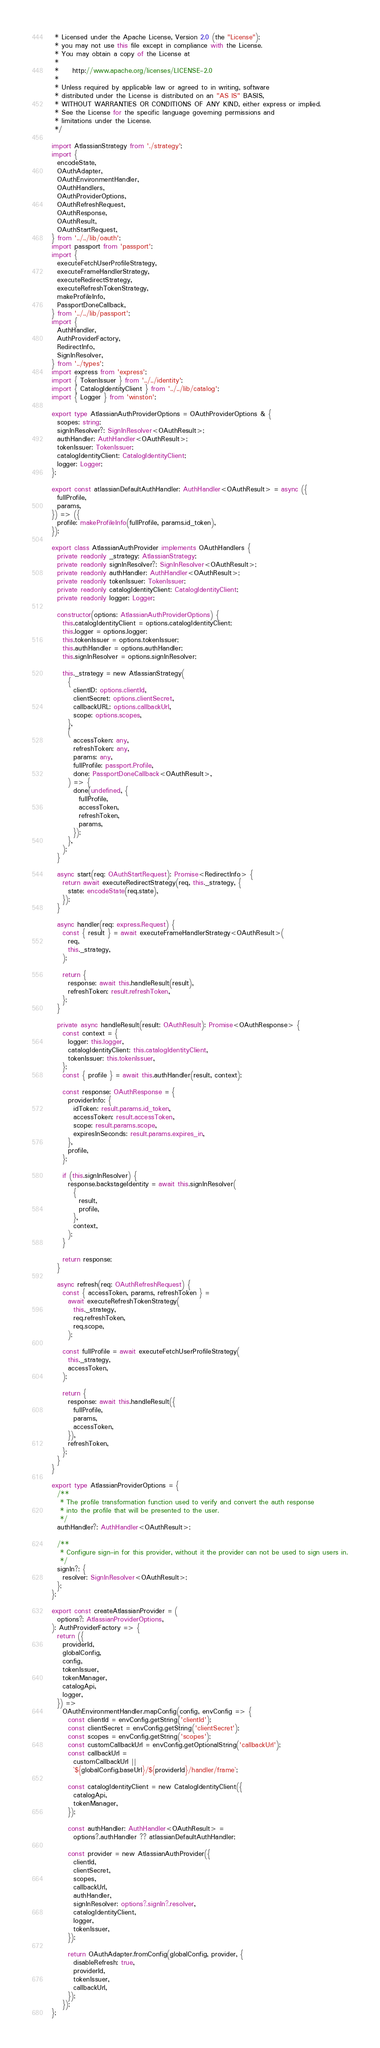<code> <loc_0><loc_0><loc_500><loc_500><_TypeScript_> * Licensed under the Apache License, Version 2.0 (the "License");
 * you may not use this file except in compliance with the License.
 * You may obtain a copy of the License at
 *
 *     http://www.apache.org/licenses/LICENSE-2.0
 *
 * Unless required by applicable law or agreed to in writing, software
 * distributed under the License is distributed on an "AS IS" BASIS,
 * WITHOUT WARRANTIES OR CONDITIONS OF ANY KIND, either express or implied.
 * See the License for the specific language governing permissions and
 * limitations under the License.
 */

import AtlassianStrategy from './strategy';
import {
  encodeState,
  OAuthAdapter,
  OAuthEnvironmentHandler,
  OAuthHandlers,
  OAuthProviderOptions,
  OAuthRefreshRequest,
  OAuthResponse,
  OAuthResult,
  OAuthStartRequest,
} from '../../lib/oauth';
import passport from 'passport';
import {
  executeFetchUserProfileStrategy,
  executeFrameHandlerStrategy,
  executeRedirectStrategy,
  executeRefreshTokenStrategy,
  makeProfileInfo,
  PassportDoneCallback,
} from '../../lib/passport';
import {
  AuthHandler,
  AuthProviderFactory,
  RedirectInfo,
  SignInResolver,
} from '../types';
import express from 'express';
import { TokenIssuer } from '../../identity';
import { CatalogIdentityClient } from '../../lib/catalog';
import { Logger } from 'winston';

export type AtlassianAuthProviderOptions = OAuthProviderOptions & {
  scopes: string;
  signInResolver?: SignInResolver<OAuthResult>;
  authHandler: AuthHandler<OAuthResult>;
  tokenIssuer: TokenIssuer;
  catalogIdentityClient: CatalogIdentityClient;
  logger: Logger;
};

export const atlassianDefaultAuthHandler: AuthHandler<OAuthResult> = async ({
  fullProfile,
  params,
}) => ({
  profile: makeProfileInfo(fullProfile, params.id_token),
});

export class AtlassianAuthProvider implements OAuthHandlers {
  private readonly _strategy: AtlassianStrategy;
  private readonly signInResolver?: SignInResolver<OAuthResult>;
  private readonly authHandler: AuthHandler<OAuthResult>;
  private readonly tokenIssuer: TokenIssuer;
  private readonly catalogIdentityClient: CatalogIdentityClient;
  private readonly logger: Logger;

  constructor(options: AtlassianAuthProviderOptions) {
    this.catalogIdentityClient = options.catalogIdentityClient;
    this.logger = options.logger;
    this.tokenIssuer = options.tokenIssuer;
    this.authHandler = options.authHandler;
    this.signInResolver = options.signInResolver;

    this._strategy = new AtlassianStrategy(
      {
        clientID: options.clientId,
        clientSecret: options.clientSecret,
        callbackURL: options.callbackUrl,
        scope: options.scopes,
      },
      (
        accessToken: any,
        refreshToken: any,
        params: any,
        fullProfile: passport.Profile,
        done: PassportDoneCallback<OAuthResult>,
      ) => {
        done(undefined, {
          fullProfile,
          accessToken,
          refreshToken,
          params,
        });
      },
    );
  }

  async start(req: OAuthStartRequest): Promise<RedirectInfo> {
    return await executeRedirectStrategy(req, this._strategy, {
      state: encodeState(req.state),
    });
  }

  async handler(req: express.Request) {
    const { result } = await executeFrameHandlerStrategy<OAuthResult>(
      req,
      this._strategy,
    );

    return {
      response: await this.handleResult(result),
      refreshToken: result.refreshToken,
    };
  }

  private async handleResult(result: OAuthResult): Promise<OAuthResponse> {
    const context = {
      logger: this.logger,
      catalogIdentityClient: this.catalogIdentityClient,
      tokenIssuer: this.tokenIssuer,
    };
    const { profile } = await this.authHandler(result, context);

    const response: OAuthResponse = {
      providerInfo: {
        idToken: result.params.id_token,
        accessToken: result.accessToken,
        scope: result.params.scope,
        expiresInSeconds: result.params.expires_in,
      },
      profile,
    };

    if (this.signInResolver) {
      response.backstageIdentity = await this.signInResolver(
        {
          result,
          profile,
        },
        context,
      );
    }

    return response;
  }

  async refresh(req: OAuthRefreshRequest) {
    const { accessToken, params, refreshToken } =
      await executeRefreshTokenStrategy(
        this._strategy,
        req.refreshToken,
        req.scope,
      );

    const fullProfile = await executeFetchUserProfileStrategy(
      this._strategy,
      accessToken,
    );

    return {
      response: await this.handleResult({
        fullProfile,
        params,
        accessToken,
      }),
      refreshToken,
    };
  }
}

export type AtlassianProviderOptions = {
  /**
   * The profile transformation function used to verify and convert the auth response
   * into the profile that will be presented to the user.
   */
  authHandler?: AuthHandler<OAuthResult>;

  /**
   * Configure sign-in for this provider, without it the provider can not be used to sign users in.
   */
  signIn?: {
    resolver: SignInResolver<OAuthResult>;
  };
};

export const createAtlassianProvider = (
  options?: AtlassianProviderOptions,
): AuthProviderFactory => {
  return ({
    providerId,
    globalConfig,
    config,
    tokenIssuer,
    tokenManager,
    catalogApi,
    logger,
  }) =>
    OAuthEnvironmentHandler.mapConfig(config, envConfig => {
      const clientId = envConfig.getString('clientId');
      const clientSecret = envConfig.getString('clientSecret');
      const scopes = envConfig.getString('scopes');
      const customCallbackUrl = envConfig.getOptionalString('callbackUrl');
      const callbackUrl =
        customCallbackUrl ||
        `${globalConfig.baseUrl}/${providerId}/handler/frame`;

      const catalogIdentityClient = new CatalogIdentityClient({
        catalogApi,
        tokenManager,
      });

      const authHandler: AuthHandler<OAuthResult> =
        options?.authHandler ?? atlassianDefaultAuthHandler;

      const provider = new AtlassianAuthProvider({
        clientId,
        clientSecret,
        scopes,
        callbackUrl,
        authHandler,
        signInResolver: options?.signIn?.resolver,
        catalogIdentityClient,
        logger,
        tokenIssuer,
      });

      return OAuthAdapter.fromConfig(globalConfig, provider, {
        disableRefresh: true,
        providerId,
        tokenIssuer,
        callbackUrl,
      });
    });
};
</code> 